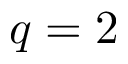<formula> <loc_0><loc_0><loc_500><loc_500>q = 2</formula> 